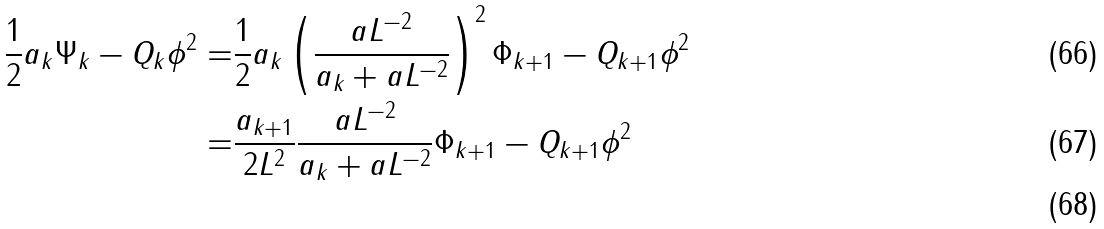<formula> <loc_0><loc_0><loc_500><loc_500>\frac { 1 } { 2 } a _ { k } \| \Psi _ { k } - Q _ { k } \phi \| ^ { 2 } = & \frac { 1 } { 2 } a _ { k } \left ( \frac { a L ^ { - 2 } } { a _ { k } + a L ^ { - 2 } } \right ) ^ { 2 } \| \Phi _ { k + 1 } - Q _ { k + 1 } \phi \| ^ { 2 } \\ = & \frac { a _ { k + 1 } } { 2 L ^ { 2 } } \frac { a L ^ { - 2 } } { a _ { k } + a L ^ { - 2 } } \| \Phi _ { k + 1 } - Q _ { k + 1 } \phi \| ^ { 2 } \\</formula> 